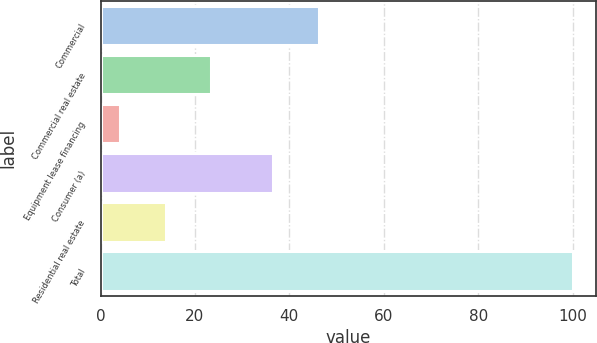Convert chart to OTSL. <chart><loc_0><loc_0><loc_500><loc_500><bar_chart><fcel>Commercial<fcel>Commercial real estate<fcel>Equipment lease financing<fcel>Consumer (a)<fcel>Residential real estate<fcel>Total<nl><fcel>46.18<fcel>23.36<fcel>4.2<fcel>36.6<fcel>13.78<fcel>100<nl></chart> 